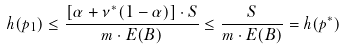<formula> <loc_0><loc_0><loc_500><loc_500>h ( p _ { 1 } ) \leq \frac { [ \alpha + \nu ^ { * } ( 1 - \alpha ) ] \cdot S } { m \cdot E ( B ) } \leq \frac { S } { m \cdot E ( B ) } = h ( p ^ { * } )</formula> 